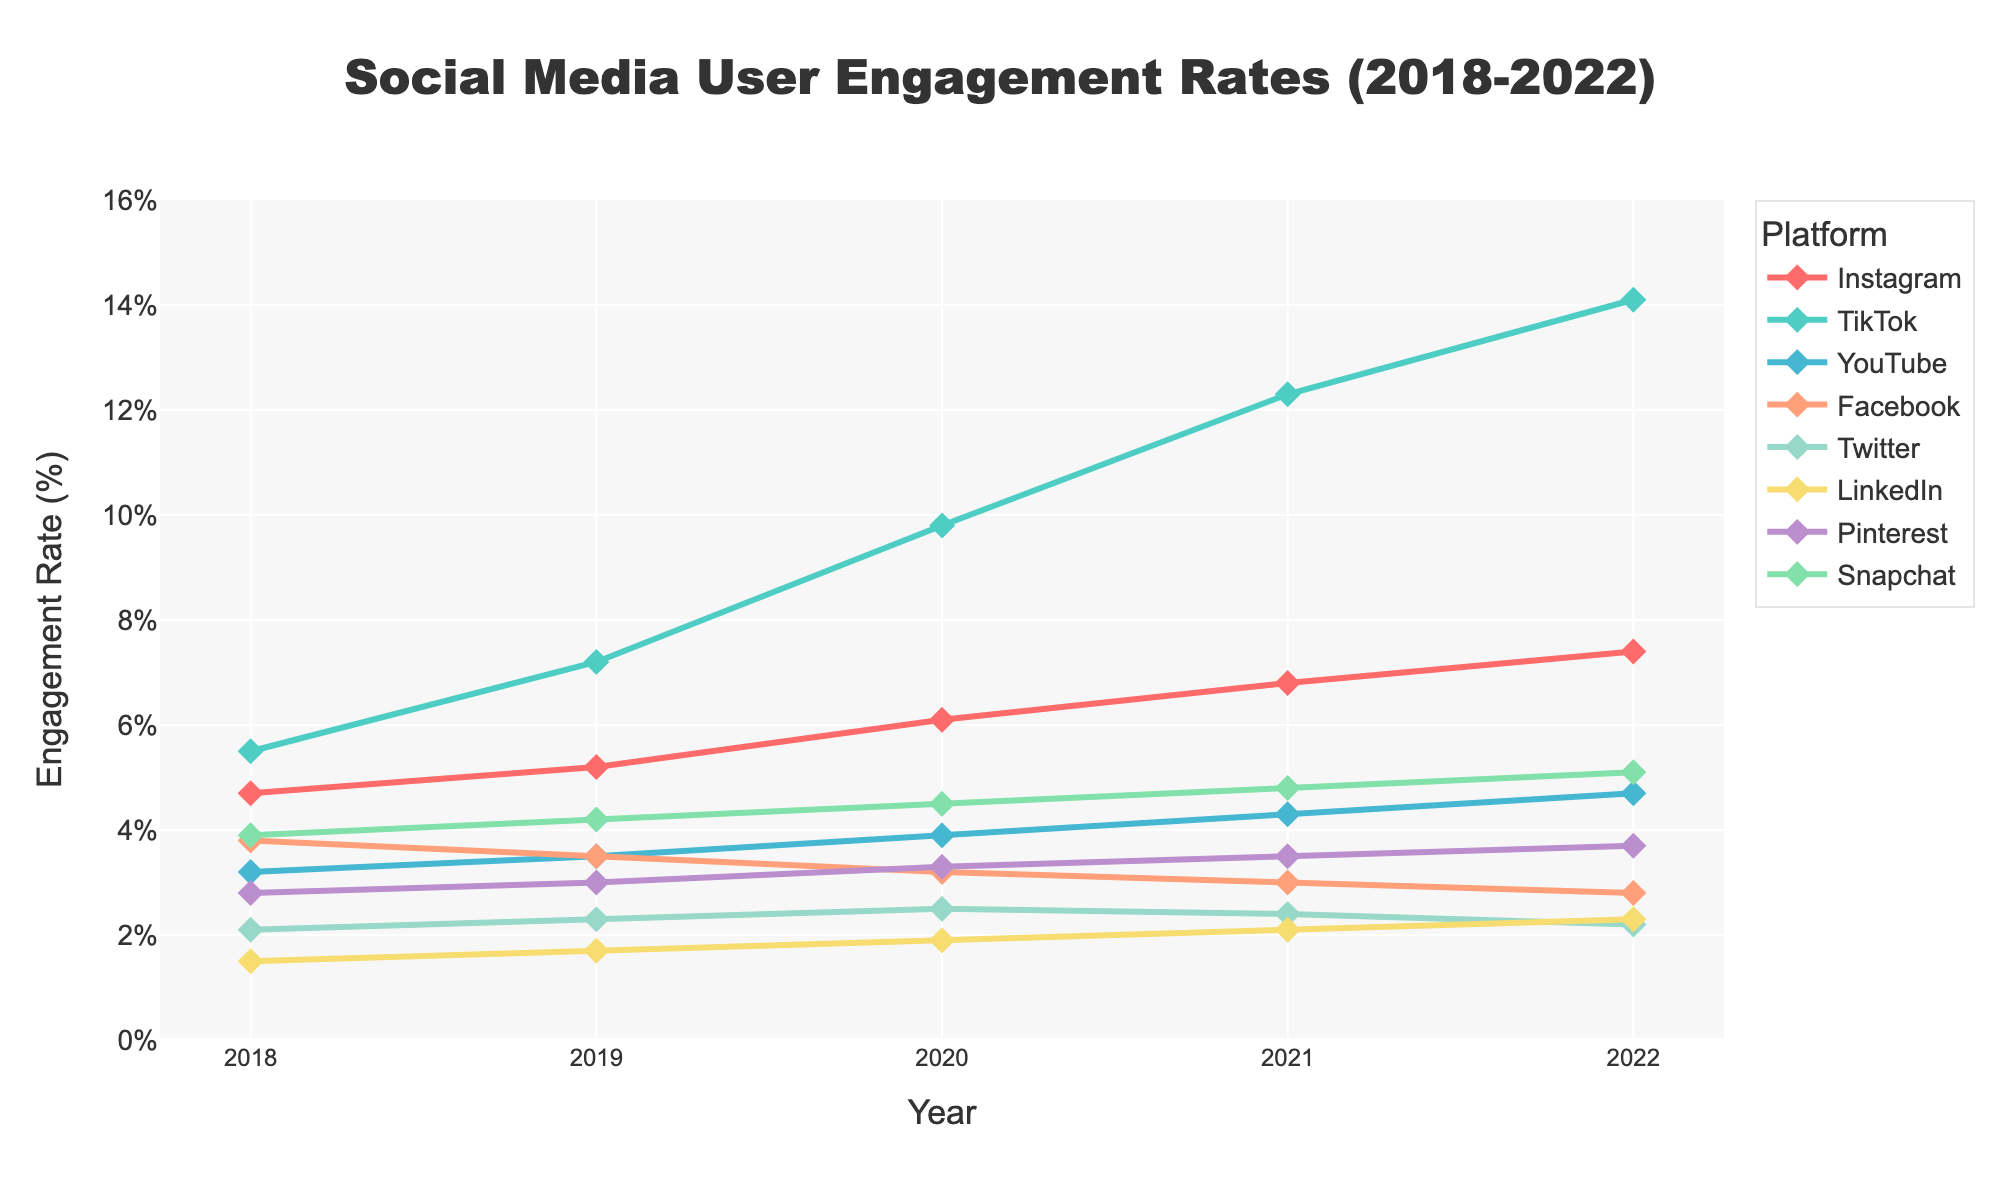What platform had the highest user engagement rate in 2022? By observing the highest point in the 2022 column, it's visible that TikTok has the highest engagement rate.
Answer: TikTok Which platform shows a decrease in user engagement from 2018 to 2022? By examining the line trends from 2018 to 2022, we can see that Facebook's engagement rate decreases.
Answer: Facebook Which two platforms had an equal engagement rate in 2019? In 2019, both Facebook and Snapchat are noted to have an engagement rate of 3.5%.
Answer: Facebook and Snapchat How much did the engagement rate for TikTok increase from 2018 to 2022? TikTok's engagement rate in 2018 is 5.5%, and in 2022 it is 14.1%. The increase is calculated as 14.1% - 5.5%.
Answer: 8.6% Which platform had the lowest engagement rate in 2020? By looking at the lowest point of the 2020 column, LinkedIn is observed to have the lowest engagement rate at 1.9%.
Answer: LinkedIn Between Instagram and YouTube, which platform had a steeper increase in user engagement from 2018 to 2022? Instagram's engagement rate increased from 4.7% to 7.4%, while YouTube's increased from 3.2% to 4.7%. Calculating the differences, Instagram had an increase of 2.7%, while YouTube increased by 1.5%. Instagram had a steeper increase.
Answer: Instagram Which platforms had an engagement rate higher than 5% in 2022? Referring to the 2022 column, platforms with engagement rates higher than 5% include Instagram, TikTok, Pinterest, and Snapchat.
Answer: Instagram, TikTok, Pinterest, and Snapchat Compare Snapchat's engagement rate growth with Twitter's from 2018 to 2022 Snapchat's engagement rate increased from 3.9% to 5.1% (1.2%). Twitter's engagement rate decreased from 2.1% to 2.2% (0.1%). Since 1.2% > 0.1%, Snapchat had higher growth.
Answer: Snapchat Which year did TikTok overtake Instagram in terms of engagement rate? Looking at the intersection of their lines, TikTok overtakes Instagram in 2019 when TikTok's engagement rate becomes higher.
Answer: 2019 